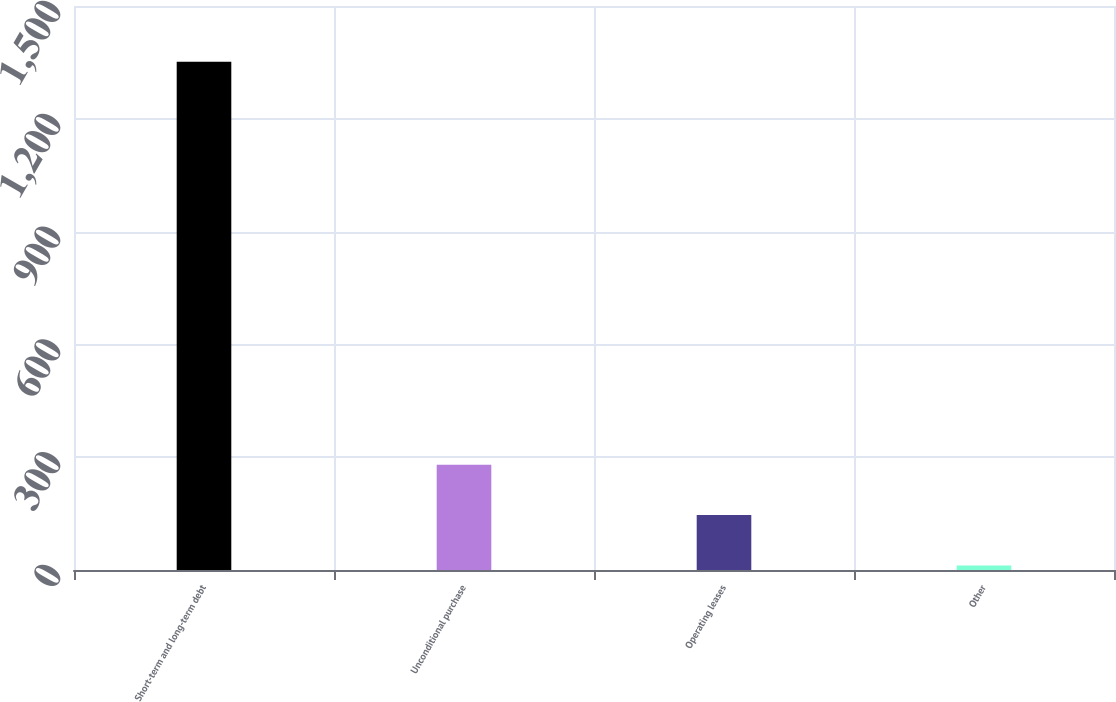Convert chart. <chart><loc_0><loc_0><loc_500><loc_500><bar_chart><fcel>Short-term and long-term debt<fcel>Unconditional purchase<fcel>Operating leases<fcel>Other<nl><fcel>1352<fcel>280<fcel>146<fcel>12<nl></chart> 